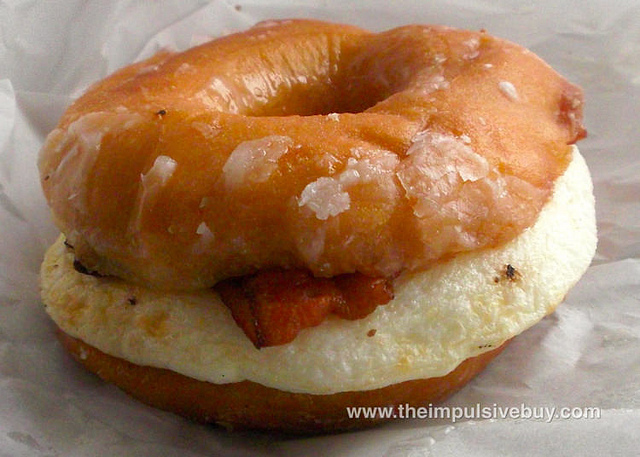Extract all visible text content from this image. WWW.theimpulsivebuy.com 